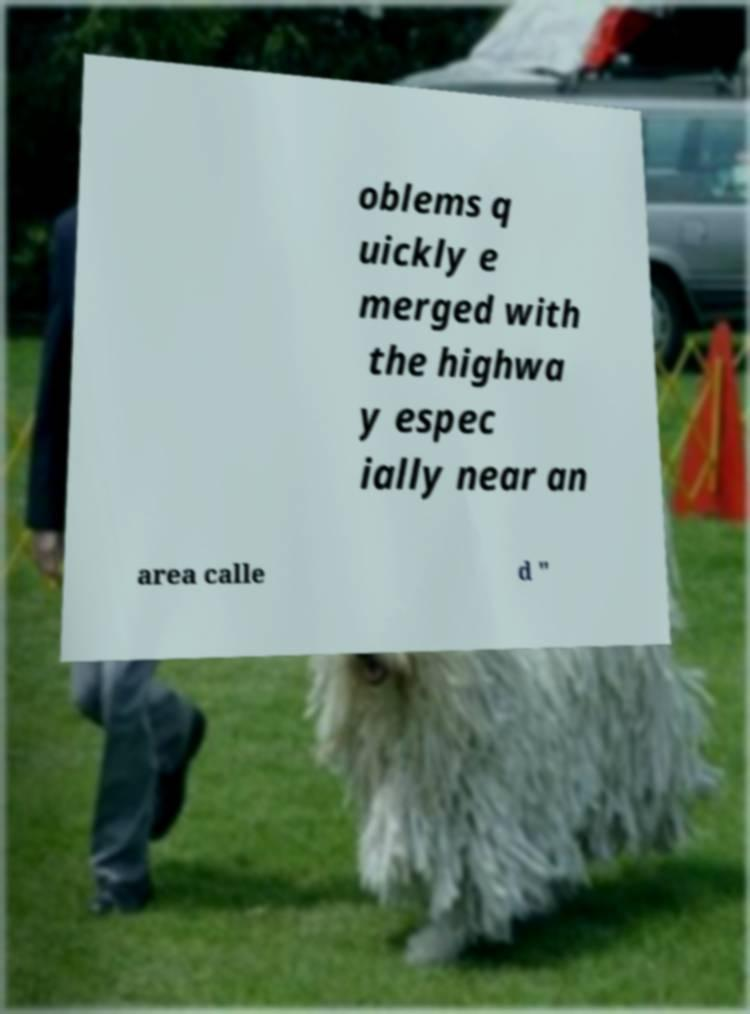Could you extract and type out the text from this image? oblems q uickly e merged with the highwa y espec ially near an area calle d " 